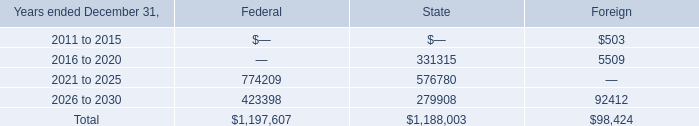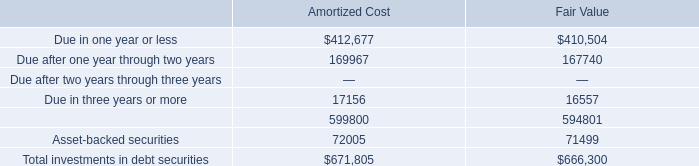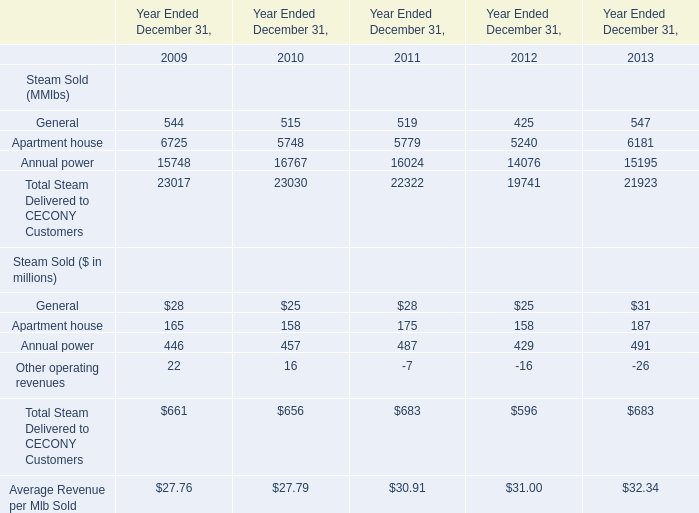What's the sum of Due after one year through two years of Amortized Cost, and Annual power of Year Ended December 31, 2010 ? 
Computations: (169967.0 + 16767.0)
Answer: 186734.0. 